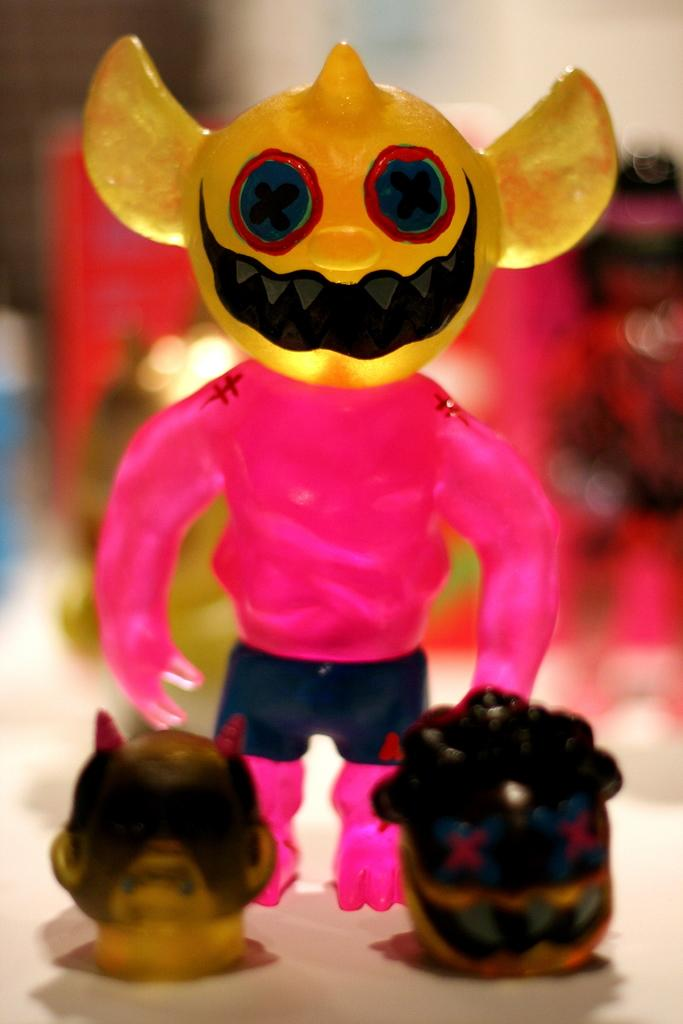What is the main subject in the center of the image? There is a cream-colored object in the center of the image. What is placed on the cream-colored object? Toys are present on the cream-colored object. Can you describe the background of the image? The background of the image is blurred. How many straws are being used to jump over the cream-colored object in the image? There are no straws or jumping activities present in the image. 